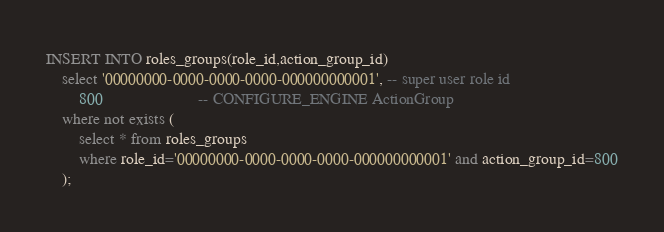Convert code to text. <code><loc_0><loc_0><loc_500><loc_500><_SQL_>INSERT INTO roles_groups(role_id,action_group_id)
	select '00000000-0000-0000-0000-000000000001', -- super user role id
		800				       -- CONFIGURE_ENGINE ActionGroup
	where not exists (
		select * from roles_groups
		where role_id='00000000-0000-0000-0000-000000000001' and action_group_id=800
	);
</code> 